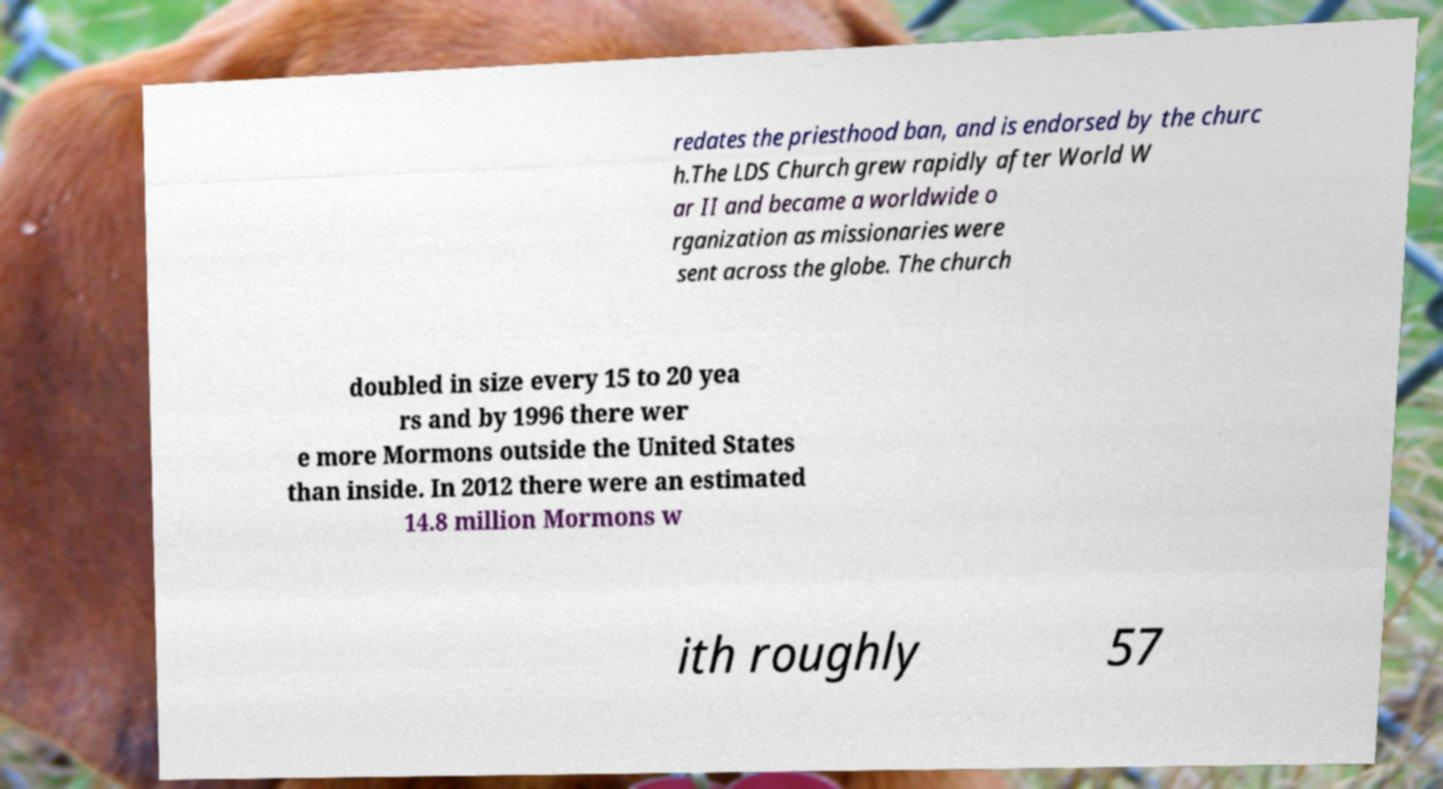Can you accurately transcribe the text from the provided image for me? redates the priesthood ban, and is endorsed by the churc h.The LDS Church grew rapidly after World W ar II and became a worldwide o rganization as missionaries were sent across the globe. The church doubled in size every 15 to 20 yea rs and by 1996 there wer e more Mormons outside the United States than inside. In 2012 there were an estimated 14.8 million Mormons w ith roughly 57 